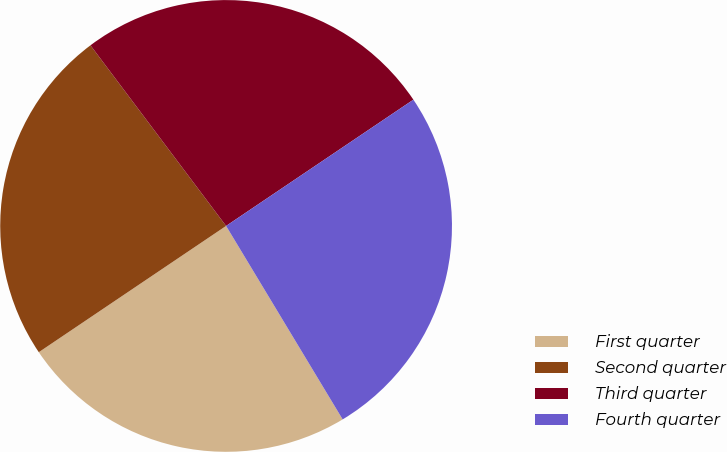Convert chart to OTSL. <chart><loc_0><loc_0><loc_500><loc_500><pie_chart><fcel>First quarter<fcel>Second quarter<fcel>Third quarter<fcel>Fourth quarter<nl><fcel>24.19%<fcel>24.19%<fcel>25.81%<fcel>25.81%<nl></chart> 